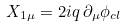Convert formula to latex. <formula><loc_0><loc_0><loc_500><loc_500>X _ { 1 \mu } = 2 i q \, \partial _ { \mu } \phi _ { c l } \,</formula> 